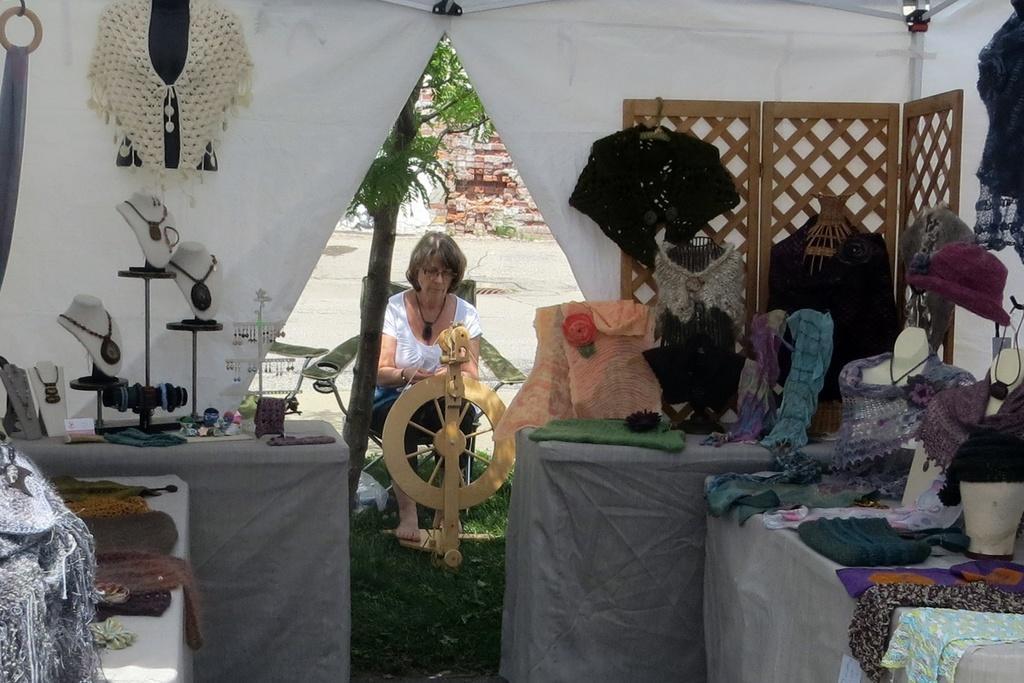In one or two sentences, can you explain what this image depicts? This picture is inside the tent, where I can see some clothes are placed on the table which is the right side of the image, we can see some ornaments are placed on the table which is on the left side of the image. Here we can see a woman wearing white color dress is sitting on the chair where we can see some object in front of her. In the background, I can see trees and the brick wall. 